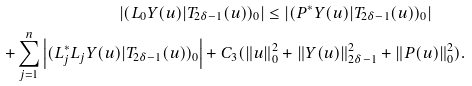<formula> <loc_0><loc_0><loc_500><loc_500>\left | ( L _ { 0 } Y ( u ) | T _ { 2 \delta - 1 } ( u ) ) _ { 0 } \right | \leq \left | ( P ^ { * } Y ( u ) | T _ { 2 \delta - 1 } ( u ) ) _ { 0 } \right | \quad \\ + \sum _ { j = 1 } ^ { n } \left | ( L _ { j } ^ { * } L _ { j } Y ( u ) | T _ { 2 \delta - 1 } ( u ) ) _ { 0 } \right | + C _ { 3 } ( \| u \| _ { 0 } ^ { 2 } + \| Y ( u ) \| _ { 2 \delta - 1 } ^ { 2 } + \| P ( u ) \| _ { 0 } ^ { 2 } ) .</formula> 